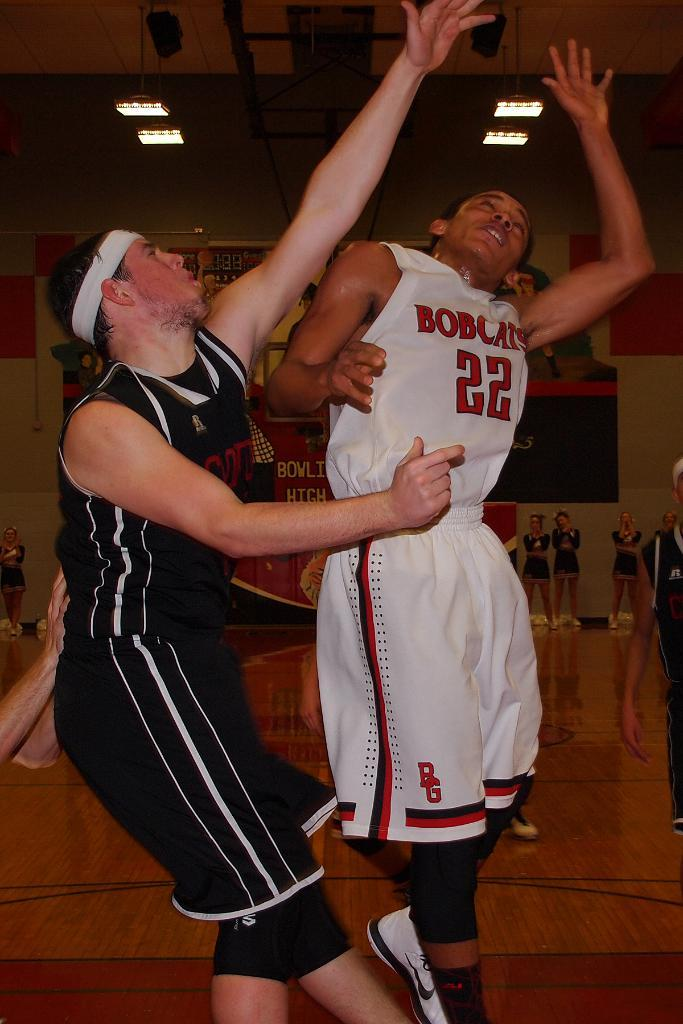<image>
Create a compact narrative representing the image presented. a Bobcats player that has the number 22 on them 